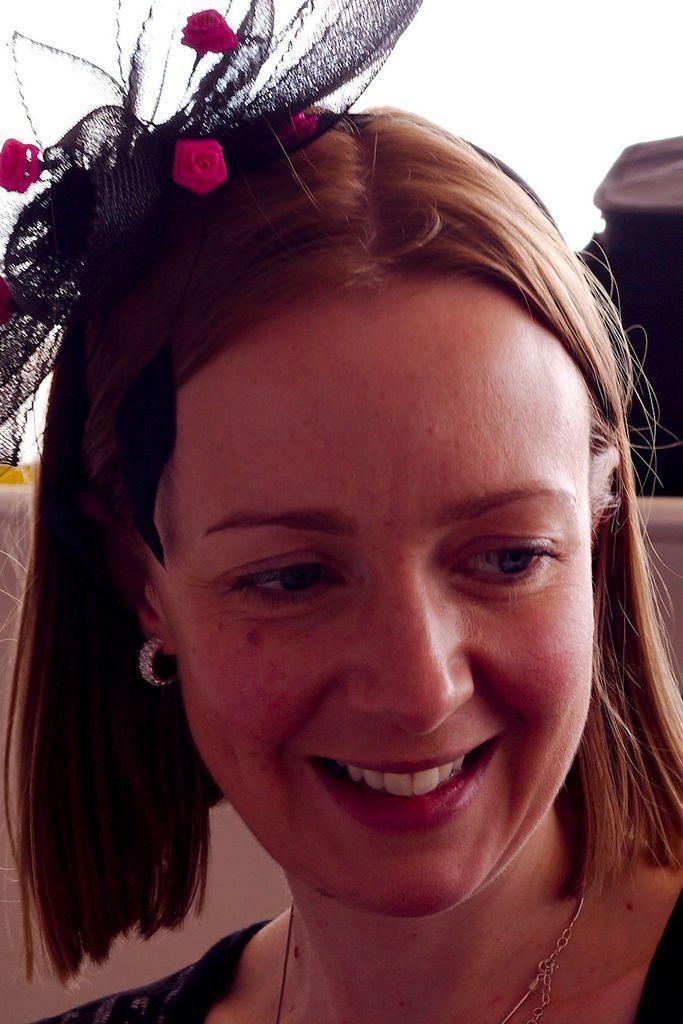Could you give a brief overview of what you see in this image? In this picture I can see there is a woman, she is looking at right side and she is wearing a black dress and a black headband with pink roses. The backdrop is plane and there is a black color object on to right. 